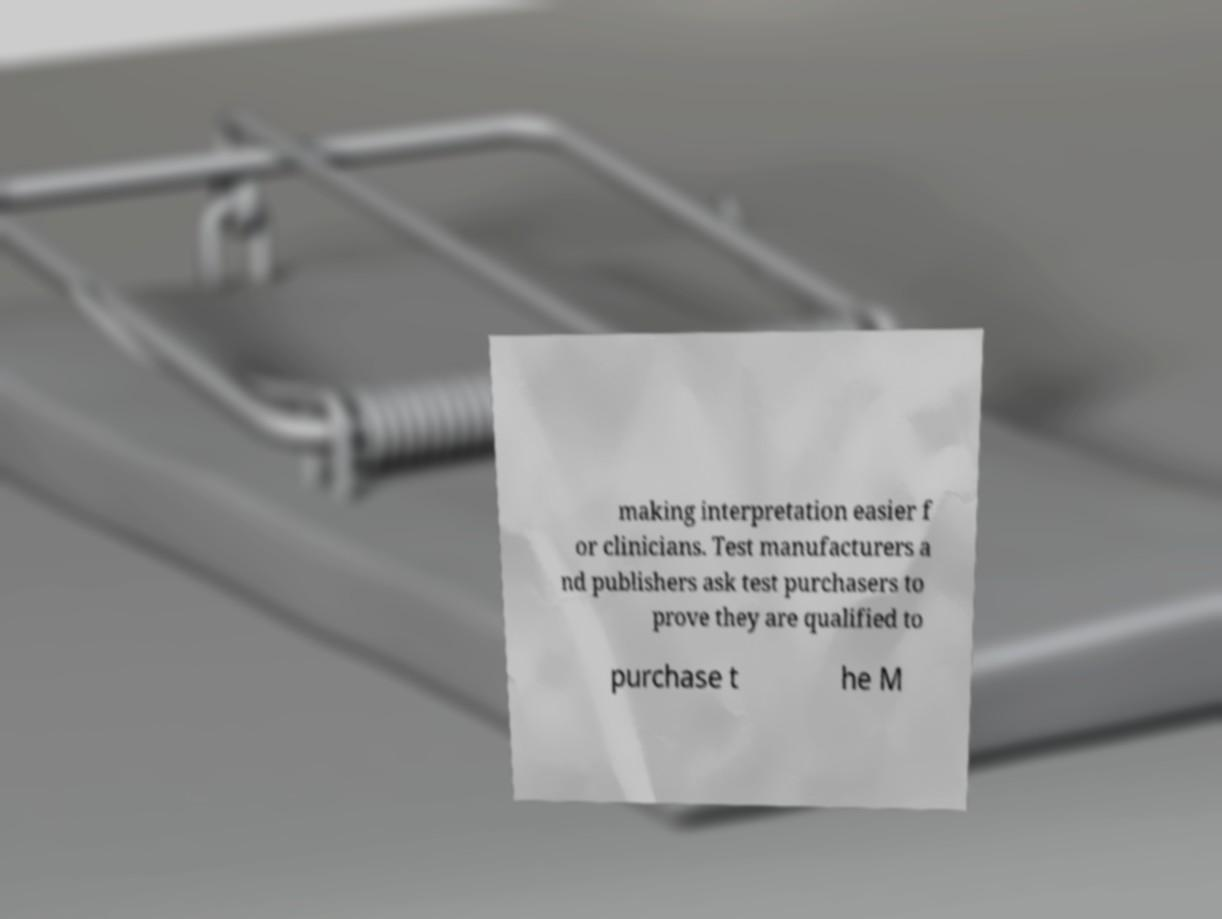Please identify and transcribe the text found in this image. making interpretation easier f or clinicians. Test manufacturers a nd publishers ask test purchasers to prove they are qualified to purchase t he M 